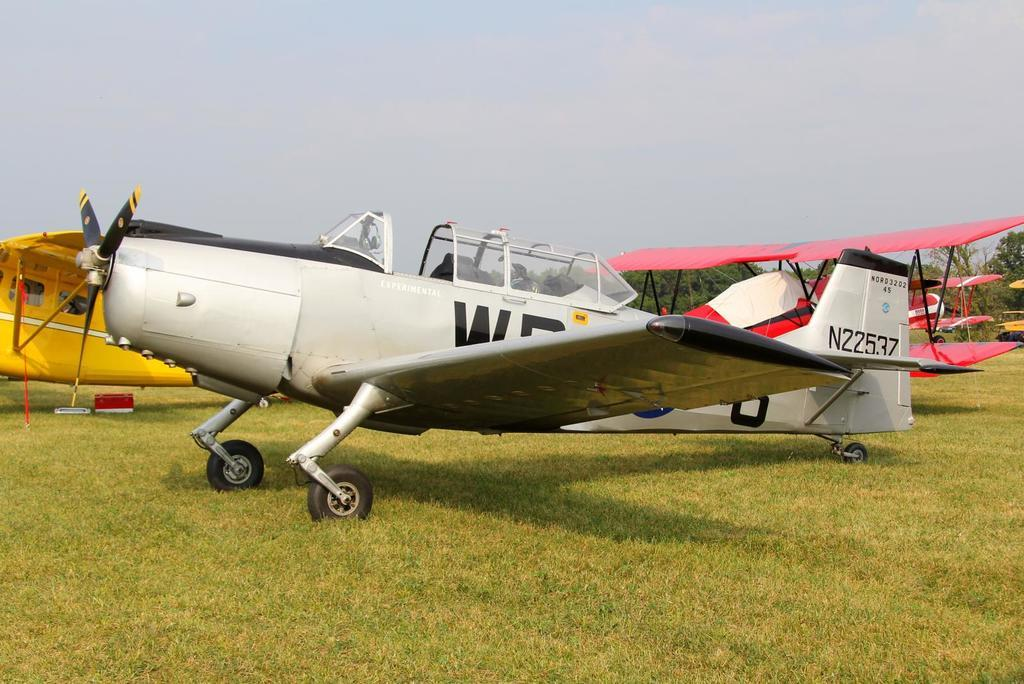Provide a one-sentence caption for the provided image. Airplane number N22537 is parked on the grass. 